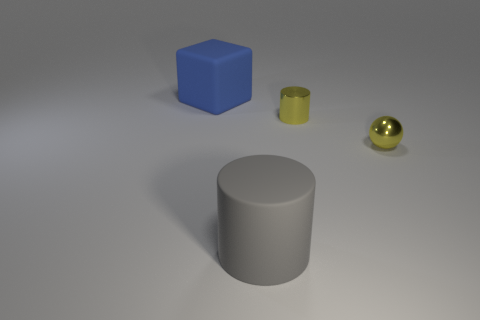How many yellow balls are the same material as the small yellow cylinder?
Your answer should be compact. 1. How many objects are big gray rubber cylinders or purple shiny cylinders?
Your response must be concise. 1. Are any tiny blue matte cubes visible?
Offer a very short reply. No. There is a cylinder to the right of the large gray matte thing to the right of the large object behind the metallic cylinder; what is it made of?
Your answer should be compact. Metal. Are there fewer rubber things that are to the right of the gray object than tiny yellow metal cylinders?
Ensure brevity in your answer.  Yes. There is a yellow object that is the same size as the yellow shiny cylinder; what is its material?
Your answer should be very brief. Metal. There is a thing that is both in front of the yellow metallic cylinder and to the left of the tiny yellow metallic ball; what size is it?
Offer a very short reply. Large. What is the size of the metallic object that is the same shape as the gray rubber thing?
Make the answer very short. Small. What number of things are purple spheres or big objects right of the cube?
Your answer should be compact. 1. There is a blue matte thing; what shape is it?
Keep it short and to the point. Cube. 